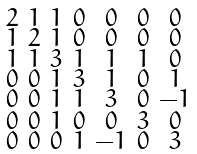<formula> <loc_0><loc_0><loc_500><loc_500>\begin{smallmatrix} 2 & 1 & 1 & 0 & 0 & 0 & 0 \\ 1 & 2 & 1 & 0 & 0 & 0 & 0 \\ 1 & 1 & 3 & 1 & 1 & 1 & 0 \\ 0 & 0 & 1 & 3 & 1 & 0 & 1 \\ 0 & 0 & 1 & 1 & 3 & 0 & - 1 \\ 0 & 0 & 1 & 0 & 0 & 3 & 0 \\ 0 & 0 & 0 & 1 & - 1 & 0 & 3 \end{smallmatrix}</formula> 